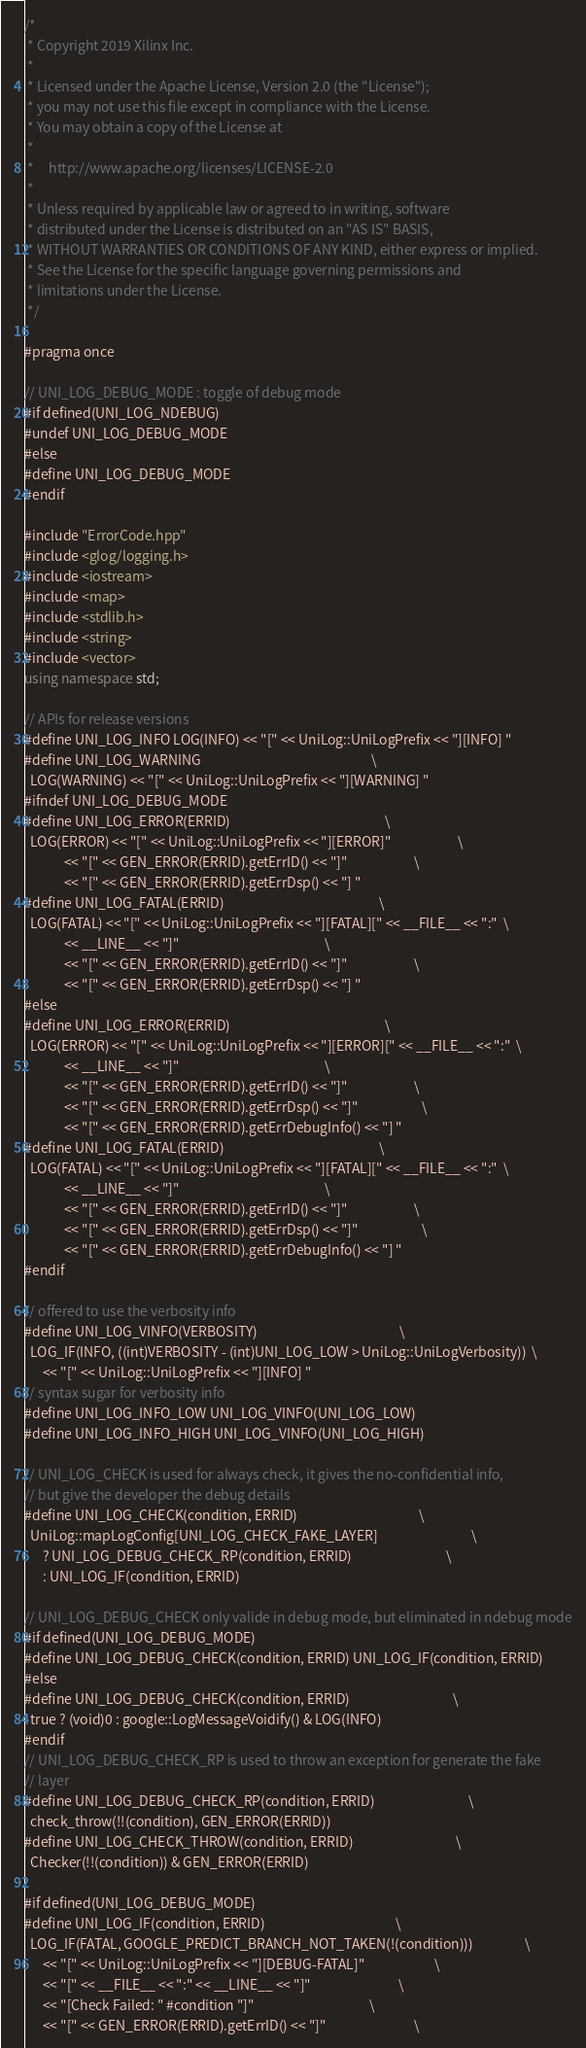Convert code to text. <code><loc_0><loc_0><loc_500><loc_500><_C++_>/*
 * Copyright 2019 Xilinx Inc.
 *
 * Licensed under the Apache License, Version 2.0 (the "License");
 * you may not use this file except in compliance with the License.
 * You may obtain a copy of the License at
 *
 *     http://www.apache.org/licenses/LICENSE-2.0
 *
 * Unless required by applicable law or agreed to in writing, software
 * distributed under the License is distributed on an "AS IS" BASIS,
 * WITHOUT WARRANTIES OR CONDITIONS OF ANY KIND, either express or implied.
 * See the License for the specific language governing permissions and
 * limitations under the License.
 */

#pragma once

// UNI_LOG_DEBUG_MODE : toggle of debug mode
#if defined(UNI_LOG_NDEBUG)
#undef UNI_LOG_DEBUG_MODE
#else
#define UNI_LOG_DEBUG_MODE
#endif

#include "ErrorCode.hpp"
#include <glog/logging.h>
#include <iostream>
#include <map>
#include <stdlib.h>
#include <string>
#include <vector>
using namespace std;

// APIs for release versions
#define UNI_LOG_INFO LOG(INFO) << "[" << UniLog::UniLogPrefix << "][INFO] "
#define UNI_LOG_WARNING                                                        \
  LOG(WARNING) << "[" << UniLog::UniLogPrefix << "][WARNING] "
#ifndef UNI_LOG_DEBUG_MODE
#define UNI_LOG_ERROR(ERRID)                                                   \
  LOG(ERROR) << "[" << UniLog::UniLogPrefix << "][ERROR]"                      \
             << "[" << GEN_ERROR(ERRID).getErrID() << "]"                      \
             << "[" << GEN_ERROR(ERRID).getErrDsp() << "] "
#define UNI_LOG_FATAL(ERRID)                                                   \
  LOG(FATAL) << "[" << UniLog::UniLogPrefix << "][FATAL][" << __FILE__ << ":"  \
             << __LINE__ << "]"                                                \
             << "[" << GEN_ERROR(ERRID).getErrID() << "]"                      \
             << "[" << GEN_ERROR(ERRID).getErrDsp() << "] "
#else
#define UNI_LOG_ERROR(ERRID)                                                   \
  LOG(ERROR) << "[" << UniLog::UniLogPrefix << "][ERROR][" << __FILE__ << ":"  \
             << __LINE__ << "]"                                                \
             << "[" << GEN_ERROR(ERRID).getErrID() << "]"                      \
             << "[" << GEN_ERROR(ERRID).getErrDsp() << "]"                     \
             << "[" << GEN_ERROR(ERRID).getErrDebugInfo() << "] "
#define UNI_LOG_FATAL(ERRID)                                                   \
  LOG(FATAL) << "[" << UniLog::UniLogPrefix << "][FATAL][" << __FILE__ << ":"  \
             << __LINE__ << "]"                                                \
             << "[" << GEN_ERROR(ERRID).getErrID() << "]"                      \
             << "[" << GEN_ERROR(ERRID).getErrDsp() << "]"                     \
             << "[" << GEN_ERROR(ERRID).getErrDebugInfo() << "] "
#endif

// offered to use the verbosity info
#define UNI_LOG_VINFO(VERBOSITY)                                               \
  LOG_IF(INFO, ((int)VERBOSITY - (int)UNI_LOG_LOW > UniLog::UniLogVerbosity))  \
      << "[" << UniLog::UniLogPrefix << "][INFO] "
// syntax sugar for verbosity info
#define UNI_LOG_INFO_LOW UNI_LOG_VINFO(UNI_LOG_LOW)
#define UNI_LOG_INFO_HIGH UNI_LOG_VINFO(UNI_LOG_HIGH)

// UNI_LOG_CHECK is used for always check, it gives the no-confidential info,
// but give the developer the debug details
#define UNI_LOG_CHECK(condition, ERRID)                                        \
  UniLog::mapLogConfig[UNI_LOG_CHECK_FAKE_LAYER]                               \
      ? UNI_LOG_DEBUG_CHECK_RP(condition, ERRID)                               \
      : UNI_LOG_IF(condition, ERRID)

// UNI_LOG_DEBUG_CHECK only valide in debug mode, but eliminated in ndebug mode
#if defined(UNI_LOG_DEBUG_MODE)
#define UNI_LOG_DEBUG_CHECK(condition, ERRID) UNI_LOG_IF(condition, ERRID)
#else
#define UNI_LOG_DEBUG_CHECK(condition, ERRID)                                  \
  true ? (void)0 : google::LogMessageVoidify() & LOG(INFO)
#endif
// UNI_LOG_DEBUG_CHECK_RP is used to throw an exception for generate the fake
// layer
#define UNI_LOG_DEBUG_CHECK_RP(condition, ERRID)                               \
  check_throw(!!(condition), GEN_ERROR(ERRID))
#define UNI_LOG_CHECK_THROW(condition, ERRID)                                  \
  Checker(!!(condition)) & GEN_ERROR(ERRID)

#if defined(UNI_LOG_DEBUG_MODE)
#define UNI_LOG_IF(condition, ERRID)                                           \
  LOG_IF(FATAL, GOOGLE_PREDICT_BRANCH_NOT_TAKEN(!(condition)))                 \
      << "[" << UniLog::UniLogPrefix << "][DEBUG-FATAL]"                       \
      << "[" << __FILE__ << ":" << __LINE__ << "]"                             \
      << "[Check Failed: " #condition "]"                                      \
      << "[" << GEN_ERROR(ERRID).getErrID() << "]"                             \</code> 